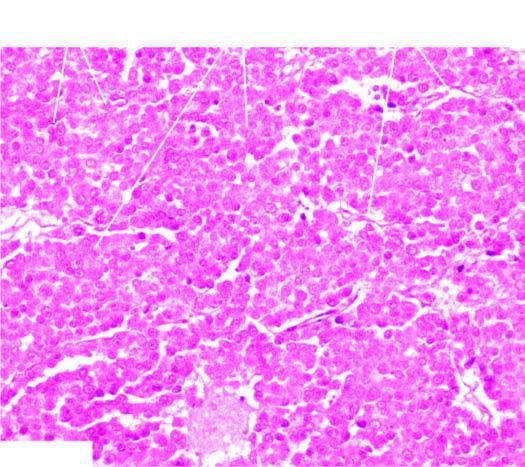what is identical to that of seminoma of the testis?
Answer the question using a single word or phrase. Histologic appearance 